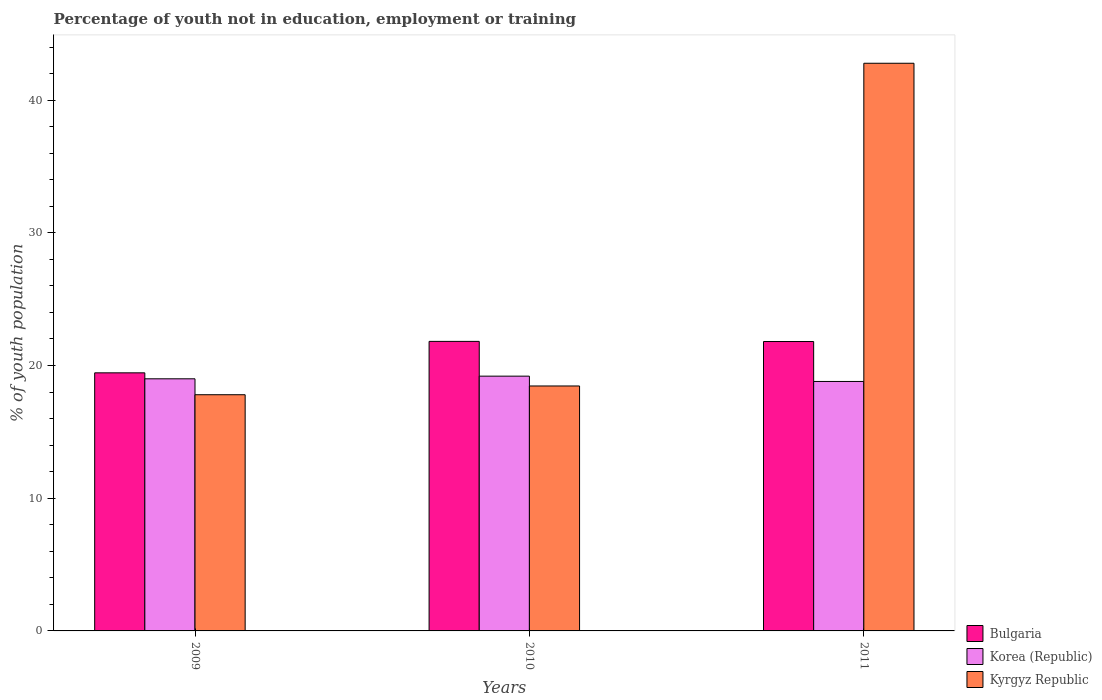How many different coloured bars are there?
Offer a terse response. 3. How many groups of bars are there?
Offer a terse response. 3. Are the number of bars per tick equal to the number of legend labels?
Make the answer very short. Yes. How many bars are there on the 2nd tick from the left?
Offer a terse response. 3. How many bars are there on the 1st tick from the right?
Provide a short and direct response. 3. What is the label of the 3rd group of bars from the left?
Keep it short and to the point. 2011. In how many cases, is the number of bars for a given year not equal to the number of legend labels?
Provide a short and direct response. 0. What is the percentage of unemployed youth population in in Bulgaria in 2010?
Make the answer very short. 21.82. Across all years, what is the maximum percentage of unemployed youth population in in Bulgaria?
Offer a terse response. 21.82. Across all years, what is the minimum percentage of unemployed youth population in in Bulgaria?
Make the answer very short. 19.45. In which year was the percentage of unemployed youth population in in Korea (Republic) minimum?
Keep it short and to the point. 2011. What is the total percentage of unemployed youth population in in Korea (Republic) in the graph?
Offer a very short reply. 57. What is the difference between the percentage of unemployed youth population in in Korea (Republic) in 2009 and that in 2010?
Offer a terse response. -0.2. What is the difference between the percentage of unemployed youth population in in Bulgaria in 2011 and the percentage of unemployed youth population in in Korea (Republic) in 2010?
Offer a very short reply. 2.61. What is the average percentage of unemployed youth population in in Bulgaria per year?
Provide a succinct answer. 21.03. In the year 2010, what is the difference between the percentage of unemployed youth population in in Kyrgyz Republic and percentage of unemployed youth population in in Korea (Republic)?
Keep it short and to the point. -0.74. What is the ratio of the percentage of unemployed youth population in in Bulgaria in 2009 to that in 2011?
Ensure brevity in your answer.  0.89. Is the percentage of unemployed youth population in in Bulgaria in 2009 less than that in 2010?
Offer a terse response. Yes. Is the difference between the percentage of unemployed youth population in in Kyrgyz Republic in 2010 and 2011 greater than the difference between the percentage of unemployed youth population in in Korea (Republic) in 2010 and 2011?
Ensure brevity in your answer.  No. What is the difference between the highest and the second highest percentage of unemployed youth population in in Bulgaria?
Your answer should be compact. 0.01. What is the difference between the highest and the lowest percentage of unemployed youth population in in Bulgaria?
Make the answer very short. 2.37. What does the 2nd bar from the left in 2009 represents?
Provide a short and direct response. Korea (Republic). How many bars are there?
Provide a succinct answer. 9. How many years are there in the graph?
Your answer should be very brief. 3. Are the values on the major ticks of Y-axis written in scientific E-notation?
Provide a short and direct response. No. Does the graph contain any zero values?
Your answer should be very brief. No. Does the graph contain grids?
Provide a short and direct response. No. Where does the legend appear in the graph?
Your answer should be compact. Bottom right. How many legend labels are there?
Your response must be concise. 3. What is the title of the graph?
Offer a terse response. Percentage of youth not in education, employment or training. What is the label or title of the Y-axis?
Your answer should be very brief. % of youth population. What is the % of youth population of Bulgaria in 2009?
Keep it short and to the point. 19.45. What is the % of youth population of Kyrgyz Republic in 2009?
Your answer should be very brief. 17.8. What is the % of youth population of Bulgaria in 2010?
Keep it short and to the point. 21.82. What is the % of youth population of Korea (Republic) in 2010?
Your answer should be very brief. 19.2. What is the % of youth population of Kyrgyz Republic in 2010?
Ensure brevity in your answer.  18.46. What is the % of youth population in Bulgaria in 2011?
Keep it short and to the point. 21.81. What is the % of youth population of Korea (Republic) in 2011?
Ensure brevity in your answer.  18.8. What is the % of youth population of Kyrgyz Republic in 2011?
Offer a terse response. 42.78. Across all years, what is the maximum % of youth population in Bulgaria?
Provide a succinct answer. 21.82. Across all years, what is the maximum % of youth population of Korea (Republic)?
Provide a short and direct response. 19.2. Across all years, what is the maximum % of youth population in Kyrgyz Republic?
Provide a succinct answer. 42.78. Across all years, what is the minimum % of youth population in Bulgaria?
Ensure brevity in your answer.  19.45. Across all years, what is the minimum % of youth population in Korea (Republic)?
Your answer should be very brief. 18.8. Across all years, what is the minimum % of youth population of Kyrgyz Republic?
Provide a succinct answer. 17.8. What is the total % of youth population of Bulgaria in the graph?
Provide a succinct answer. 63.08. What is the total % of youth population in Korea (Republic) in the graph?
Offer a very short reply. 57. What is the total % of youth population of Kyrgyz Republic in the graph?
Offer a terse response. 79.04. What is the difference between the % of youth population in Bulgaria in 2009 and that in 2010?
Give a very brief answer. -2.37. What is the difference between the % of youth population of Kyrgyz Republic in 2009 and that in 2010?
Your response must be concise. -0.66. What is the difference between the % of youth population in Bulgaria in 2009 and that in 2011?
Offer a very short reply. -2.36. What is the difference between the % of youth population of Kyrgyz Republic in 2009 and that in 2011?
Keep it short and to the point. -24.98. What is the difference between the % of youth population of Bulgaria in 2010 and that in 2011?
Your answer should be compact. 0.01. What is the difference between the % of youth population in Korea (Republic) in 2010 and that in 2011?
Offer a terse response. 0.4. What is the difference between the % of youth population of Kyrgyz Republic in 2010 and that in 2011?
Make the answer very short. -24.32. What is the difference between the % of youth population in Bulgaria in 2009 and the % of youth population in Kyrgyz Republic in 2010?
Provide a short and direct response. 0.99. What is the difference between the % of youth population in Korea (Republic) in 2009 and the % of youth population in Kyrgyz Republic in 2010?
Ensure brevity in your answer.  0.54. What is the difference between the % of youth population of Bulgaria in 2009 and the % of youth population of Korea (Republic) in 2011?
Your answer should be very brief. 0.65. What is the difference between the % of youth population of Bulgaria in 2009 and the % of youth population of Kyrgyz Republic in 2011?
Offer a very short reply. -23.33. What is the difference between the % of youth population of Korea (Republic) in 2009 and the % of youth population of Kyrgyz Republic in 2011?
Make the answer very short. -23.78. What is the difference between the % of youth population of Bulgaria in 2010 and the % of youth population of Korea (Republic) in 2011?
Provide a succinct answer. 3.02. What is the difference between the % of youth population of Bulgaria in 2010 and the % of youth population of Kyrgyz Republic in 2011?
Your answer should be compact. -20.96. What is the difference between the % of youth population in Korea (Republic) in 2010 and the % of youth population in Kyrgyz Republic in 2011?
Provide a succinct answer. -23.58. What is the average % of youth population in Bulgaria per year?
Offer a very short reply. 21.03. What is the average % of youth population of Kyrgyz Republic per year?
Give a very brief answer. 26.35. In the year 2009, what is the difference between the % of youth population of Bulgaria and % of youth population of Korea (Republic)?
Offer a terse response. 0.45. In the year 2009, what is the difference between the % of youth population in Bulgaria and % of youth population in Kyrgyz Republic?
Give a very brief answer. 1.65. In the year 2009, what is the difference between the % of youth population of Korea (Republic) and % of youth population of Kyrgyz Republic?
Provide a succinct answer. 1.2. In the year 2010, what is the difference between the % of youth population in Bulgaria and % of youth population in Korea (Republic)?
Ensure brevity in your answer.  2.62. In the year 2010, what is the difference between the % of youth population in Bulgaria and % of youth population in Kyrgyz Republic?
Your answer should be very brief. 3.36. In the year 2010, what is the difference between the % of youth population in Korea (Republic) and % of youth population in Kyrgyz Republic?
Give a very brief answer. 0.74. In the year 2011, what is the difference between the % of youth population of Bulgaria and % of youth population of Korea (Republic)?
Keep it short and to the point. 3.01. In the year 2011, what is the difference between the % of youth population in Bulgaria and % of youth population in Kyrgyz Republic?
Provide a short and direct response. -20.97. In the year 2011, what is the difference between the % of youth population in Korea (Republic) and % of youth population in Kyrgyz Republic?
Offer a terse response. -23.98. What is the ratio of the % of youth population of Bulgaria in 2009 to that in 2010?
Your answer should be very brief. 0.89. What is the ratio of the % of youth population of Korea (Republic) in 2009 to that in 2010?
Offer a terse response. 0.99. What is the ratio of the % of youth population in Kyrgyz Republic in 2009 to that in 2010?
Your answer should be very brief. 0.96. What is the ratio of the % of youth population of Bulgaria in 2009 to that in 2011?
Ensure brevity in your answer.  0.89. What is the ratio of the % of youth population of Korea (Republic) in 2009 to that in 2011?
Offer a terse response. 1.01. What is the ratio of the % of youth population in Kyrgyz Republic in 2009 to that in 2011?
Your answer should be compact. 0.42. What is the ratio of the % of youth population of Bulgaria in 2010 to that in 2011?
Your response must be concise. 1. What is the ratio of the % of youth population of Korea (Republic) in 2010 to that in 2011?
Offer a very short reply. 1.02. What is the ratio of the % of youth population of Kyrgyz Republic in 2010 to that in 2011?
Make the answer very short. 0.43. What is the difference between the highest and the second highest % of youth population in Kyrgyz Republic?
Ensure brevity in your answer.  24.32. What is the difference between the highest and the lowest % of youth population of Bulgaria?
Provide a short and direct response. 2.37. What is the difference between the highest and the lowest % of youth population of Korea (Republic)?
Offer a very short reply. 0.4. What is the difference between the highest and the lowest % of youth population in Kyrgyz Republic?
Keep it short and to the point. 24.98. 